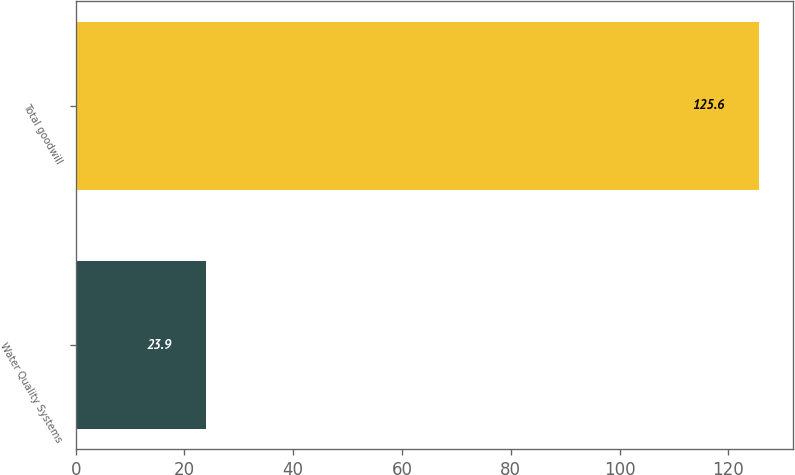Convert chart. <chart><loc_0><loc_0><loc_500><loc_500><bar_chart><fcel>Water Quality Systems<fcel>Total goodwill<nl><fcel>23.9<fcel>125.6<nl></chart> 